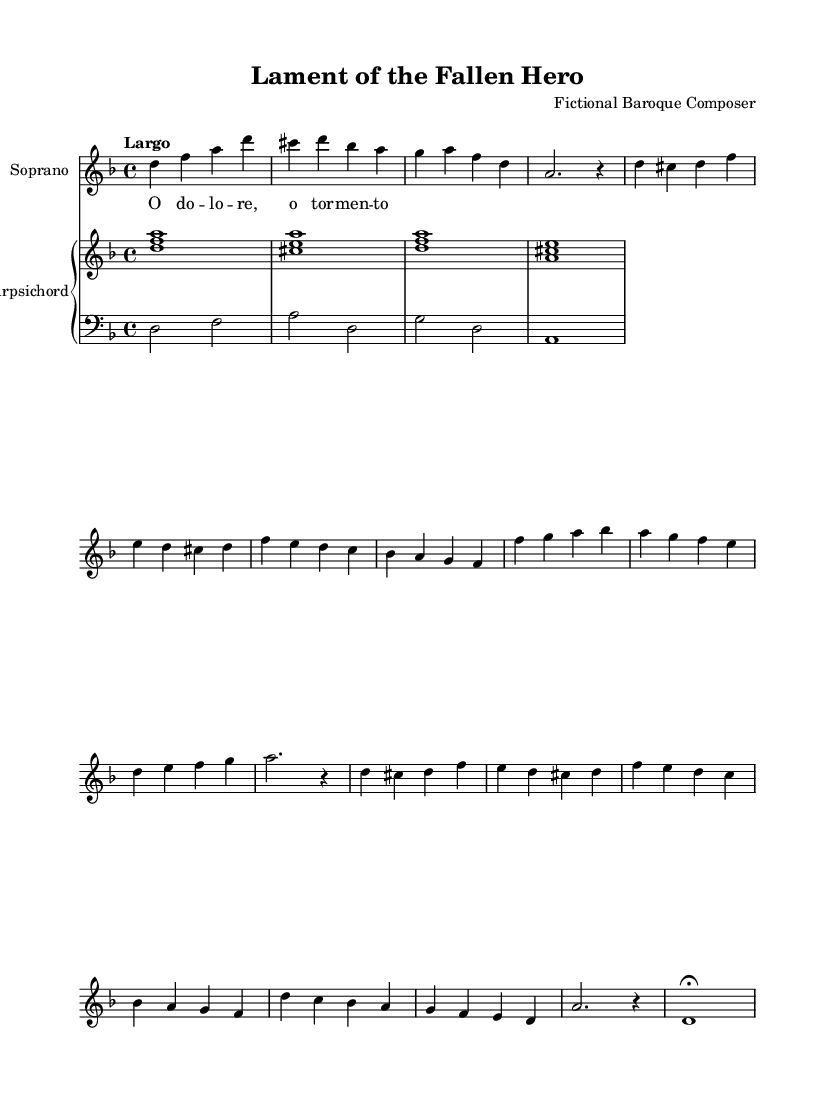What is the key signature of this music? The key signature has two flats, which corresponds to the key of D minor. This can be identified by looking at the key signature section at the beginning of the staff.
Answer: D minor What is the time signature of the piece? The time signature is indicated at the start of the music with a "4/4" marking, which means there are four beats in a measure and a quarter note receives one beat.
Answer: 4/4 What is the tempo marking of this piece? The tempo marking is "Largo," which suggests a slow and broad pace. This is indicated above the music staff at the beginning of the piece.
Answer: Largo How many sections are in the piece? The piece consists of an A section, a B section, an abbreviated A' section, and a Coda, totaling four distinct parts. This can be inferred from the structure indicated in the music with sectional labels.
Answer: Four What is the texture of the music? The texture is homophonic, as it features a clear melody in the soprano voice supported by chordal accompaniment from the harpsichord. This is evidenced by the presence of a single melody line along with harmonic support in the piano part.
Answer: Homophonic In which context could this aria be appropriately used? This aria could be used in a dramatic scene portraying sorrow or lamentation, as suggested by its title "Lament of the Fallen Hero" and its musical characteristics. The emotional content of the lyrics and the slow tempo contribute to its suitability for such contexts.
Answer: Dramatic scenes 